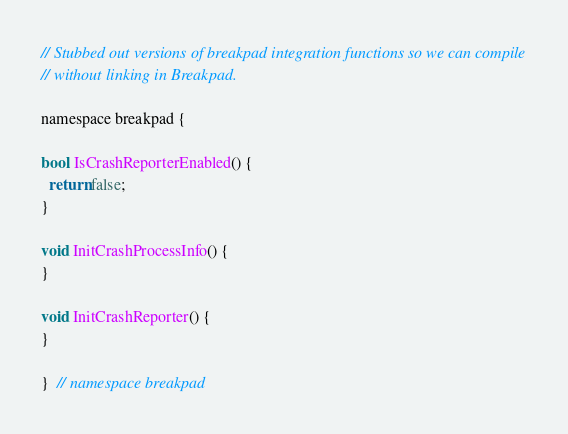<code> <loc_0><loc_0><loc_500><loc_500><_ObjectiveC_>// Stubbed out versions of breakpad integration functions so we can compile
// without linking in Breakpad.

namespace breakpad {

bool IsCrashReporterEnabled() {
  return false;
}

void InitCrashProcessInfo() {
}

void InitCrashReporter() {
}

}  // namespace breakpad
</code> 